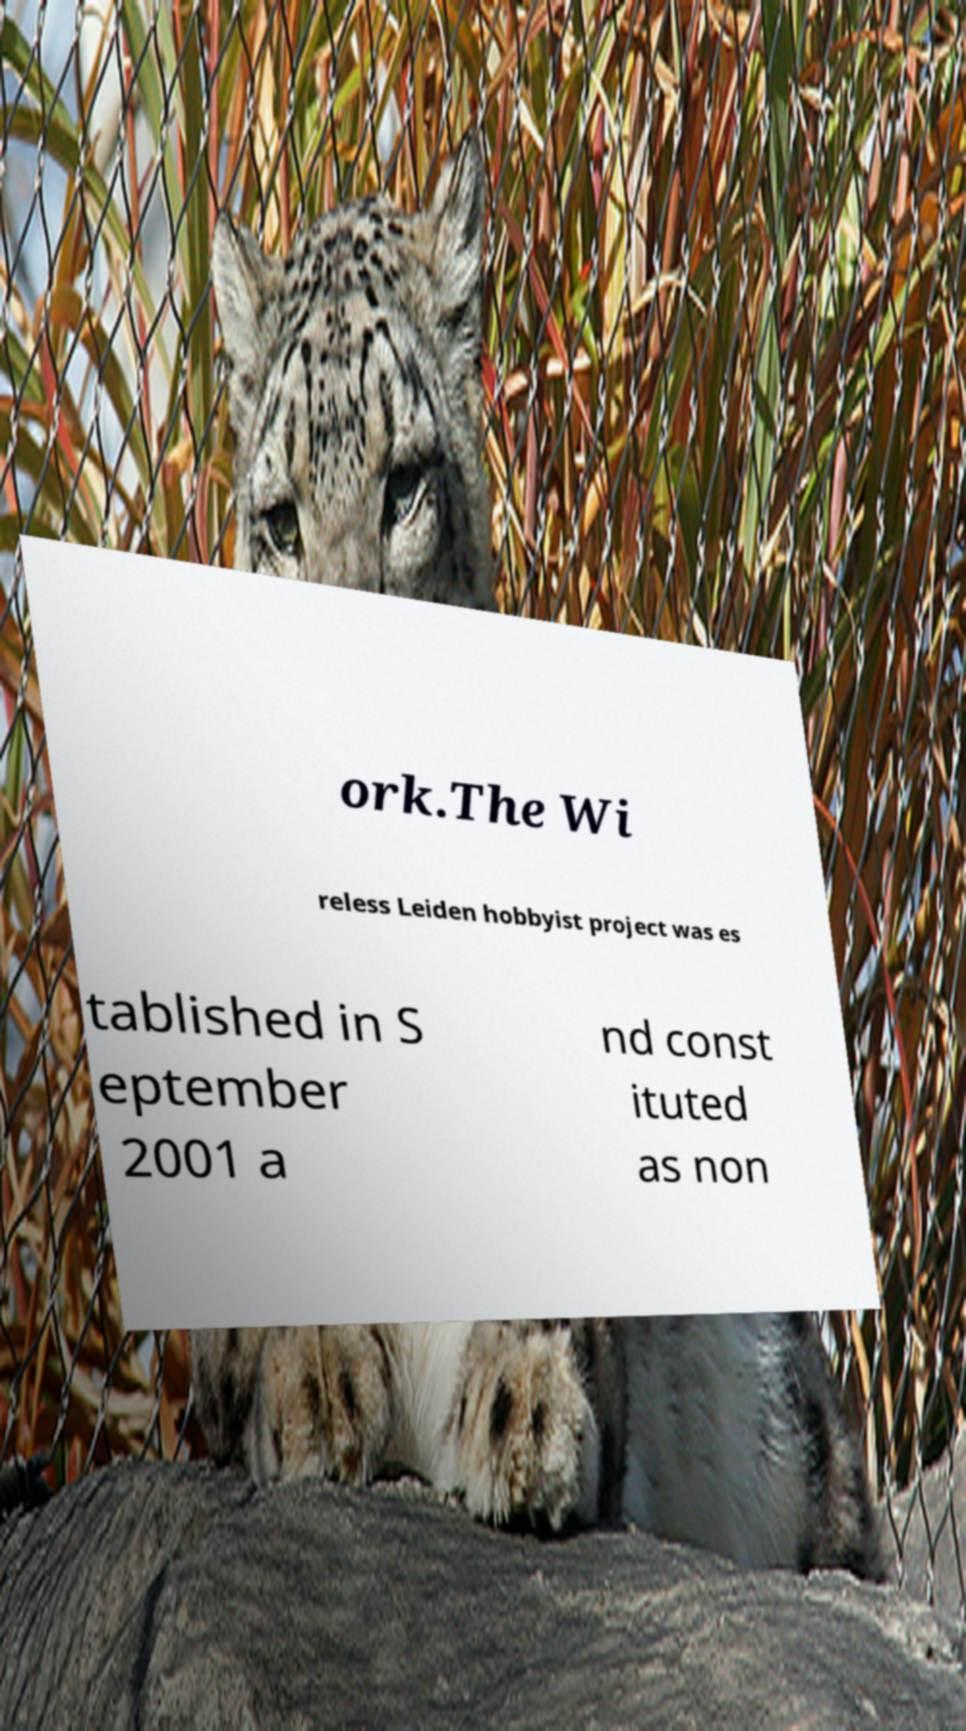Can you accurately transcribe the text from the provided image for me? ork.The Wi reless Leiden hobbyist project was es tablished in S eptember 2001 a nd const ituted as non 